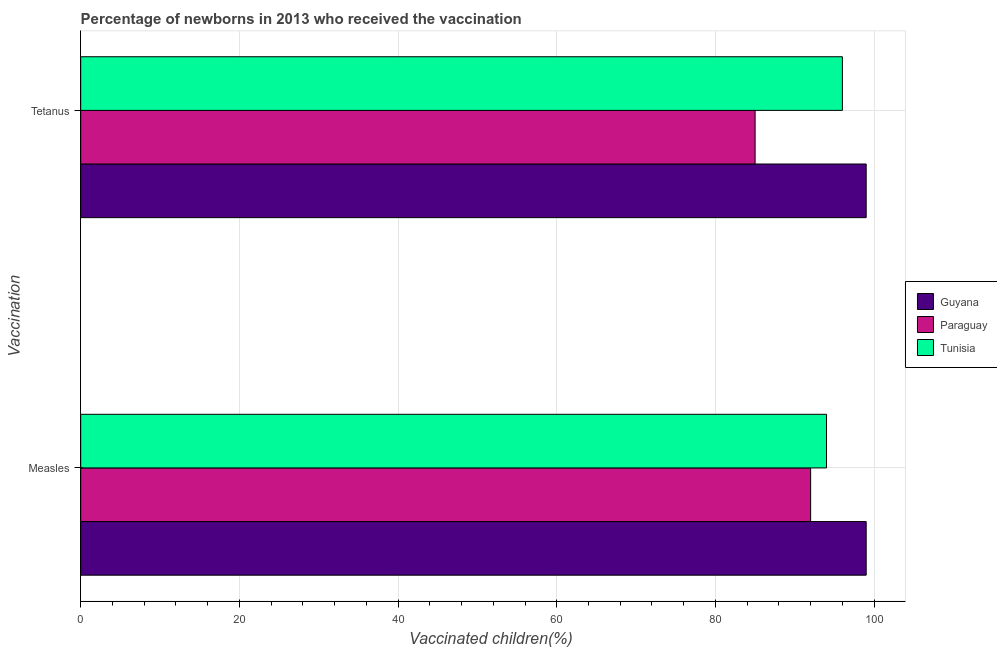How many different coloured bars are there?
Your response must be concise. 3. How many groups of bars are there?
Provide a short and direct response. 2. Are the number of bars per tick equal to the number of legend labels?
Keep it short and to the point. Yes. Are the number of bars on each tick of the Y-axis equal?
Your answer should be compact. Yes. How many bars are there on the 1st tick from the bottom?
Provide a succinct answer. 3. What is the label of the 2nd group of bars from the top?
Ensure brevity in your answer.  Measles. What is the percentage of newborns who received vaccination for tetanus in Guyana?
Keep it short and to the point. 99. Across all countries, what is the maximum percentage of newborns who received vaccination for measles?
Provide a short and direct response. 99. Across all countries, what is the minimum percentage of newborns who received vaccination for measles?
Offer a terse response. 92. In which country was the percentage of newborns who received vaccination for measles maximum?
Your answer should be very brief. Guyana. In which country was the percentage of newborns who received vaccination for measles minimum?
Provide a short and direct response. Paraguay. What is the total percentage of newborns who received vaccination for tetanus in the graph?
Ensure brevity in your answer.  280. What is the difference between the percentage of newborns who received vaccination for tetanus in Paraguay and that in Tunisia?
Your answer should be compact. -11. What is the difference between the percentage of newborns who received vaccination for measles in Tunisia and the percentage of newborns who received vaccination for tetanus in Paraguay?
Your answer should be very brief. 9. What is the average percentage of newborns who received vaccination for measles per country?
Your answer should be very brief. 95. What is the difference between the percentage of newborns who received vaccination for tetanus and percentage of newborns who received vaccination for measles in Guyana?
Provide a short and direct response. 0. In how many countries, is the percentage of newborns who received vaccination for measles greater than 64 %?
Provide a succinct answer. 3. What is the ratio of the percentage of newborns who received vaccination for tetanus in Paraguay to that in Tunisia?
Offer a terse response. 0.89. In how many countries, is the percentage of newborns who received vaccination for tetanus greater than the average percentage of newborns who received vaccination for tetanus taken over all countries?
Your answer should be compact. 2. What does the 1st bar from the top in Measles represents?
Offer a very short reply. Tunisia. What does the 3rd bar from the bottom in Tetanus represents?
Make the answer very short. Tunisia. How many bars are there?
Your answer should be compact. 6. Are the values on the major ticks of X-axis written in scientific E-notation?
Make the answer very short. No. Does the graph contain any zero values?
Offer a very short reply. No. Where does the legend appear in the graph?
Provide a succinct answer. Center right. What is the title of the graph?
Give a very brief answer. Percentage of newborns in 2013 who received the vaccination. Does "Bahrain" appear as one of the legend labels in the graph?
Your answer should be very brief. No. What is the label or title of the X-axis?
Offer a terse response. Vaccinated children(%)
. What is the label or title of the Y-axis?
Offer a very short reply. Vaccination. What is the Vaccinated children(%)
 in Paraguay in Measles?
Provide a short and direct response. 92. What is the Vaccinated children(%)
 of Tunisia in Measles?
Your answer should be compact. 94. What is the Vaccinated children(%)
 in Paraguay in Tetanus?
Your answer should be very brief. 85. What is the Vaccinated children(%)
 in Tunisia in Tetanus?
Offer a very short reply. 96. Across all Vaccination, what is the maximum Vaccinated children(%)
 of Guyana?
Ensure brevity in your answer.  99. Across all Vaccination, what is the maximum Vaccinated children(%)
 of Paraguay?
Make the answer very short. 92. Across all Vaccination, what is the maximum Vaccinated children(%)
 in Tunisia?
Your response must be concise. 96. Across all Vaccination, what is the minimum Vaccinated children(%)
 in Tunisia?
Your answer should be compact. 94. What is the total Vaccinated children(%)
 of Guyana in the graph?
Ensure brevity in your answer.  198. What is the total Vaccinated children(%)
 in Paraguay in the graph?
Offer a very short reply. 177. What is the total Vaccinated children(%)
 of Tunisia in the graph?
Your answer should be very brief. 190. What is the difference between the Vaccinated children(%)
 of Paraguay in Measles and that in Tetanus?
Provide a succinct answer. 7. What is the difference between the Vaccinated children(%)
 of Tunisia in Measles and that in Tetanus?
Provide a succinct answer. -2. What is the difference between the Vaccinated children(%)
 of Guyana in Measles and the Vaccinated children(%)
 of Paraguay in Tetanus?
Offer a terse response. 14. What is the difference between the Vaccinated children(%)
 of Guyana in Measles and the Vaccinated children(%)
 of Tunisia in Tetanus?
Provide a short and direct response. 3. What is the difference between the Vaccinated children(%)
 in Paraguay in Measles and the Vaccinated children(%)
 in Tunisia in Tetanus?
Offer a very short reply. -4. What is the average Vaccinated children(%)
 in Paraguay per Vaccination?
Provide a short and direct response. 88.5. What is the difference between the Vaccinated children(%)
 in Guyana and Vaccinated children(%)
 in Paraguay in Measles?
Provide a succinct answer. 7. What is the difference between the Vaccinated children(%)
 in Guyana and Vaccinated children(%)
 in Tunisia in Measles?
Your answer should be very brief. 5. What is the difference between the Vaccinated children(%)
 of Paraguay and Vaccinated children(%)
 of Tunisia in Measles?
Provide a short and direct response. -2. What is the difference between the Vaccinated children(%)
 of Guyana and Vaccinated children(%)
 of Tunisia in Tetanus?
Ensure brevity in your answer.  3. What is the ratio of the Vaccinated children(%)
 of Guyana in Measles to that in Tetanus?
Give a very brief answer. 1. What is the ratio of the Vaccinated children(%)
 of Paraguay in Measles to that in Tetanus?
Provide a short and direct response. 1.08. What is the ratio of the Vaccinated children(%)
 in Tunisia in Measles to that in Tetanus?
Give a very brief answer. 0.98. What is the difference between the highest and the second highest Vaccinated children(%)
 of Paraguay?
Your response must be concise. 7. What is the difference between the highest and the lowest Vaccinated children(%)
 in Guyana?
Provide a short and direct response. 0. What is the difference between the highest and the lowest Vaccinated children(%)
 of Paraguay?
Make the answer very short. 7. What is the difference between the highest and the lowest Vaccinated children(%)
 in Tunisia?
Offer a terse response. 2. 